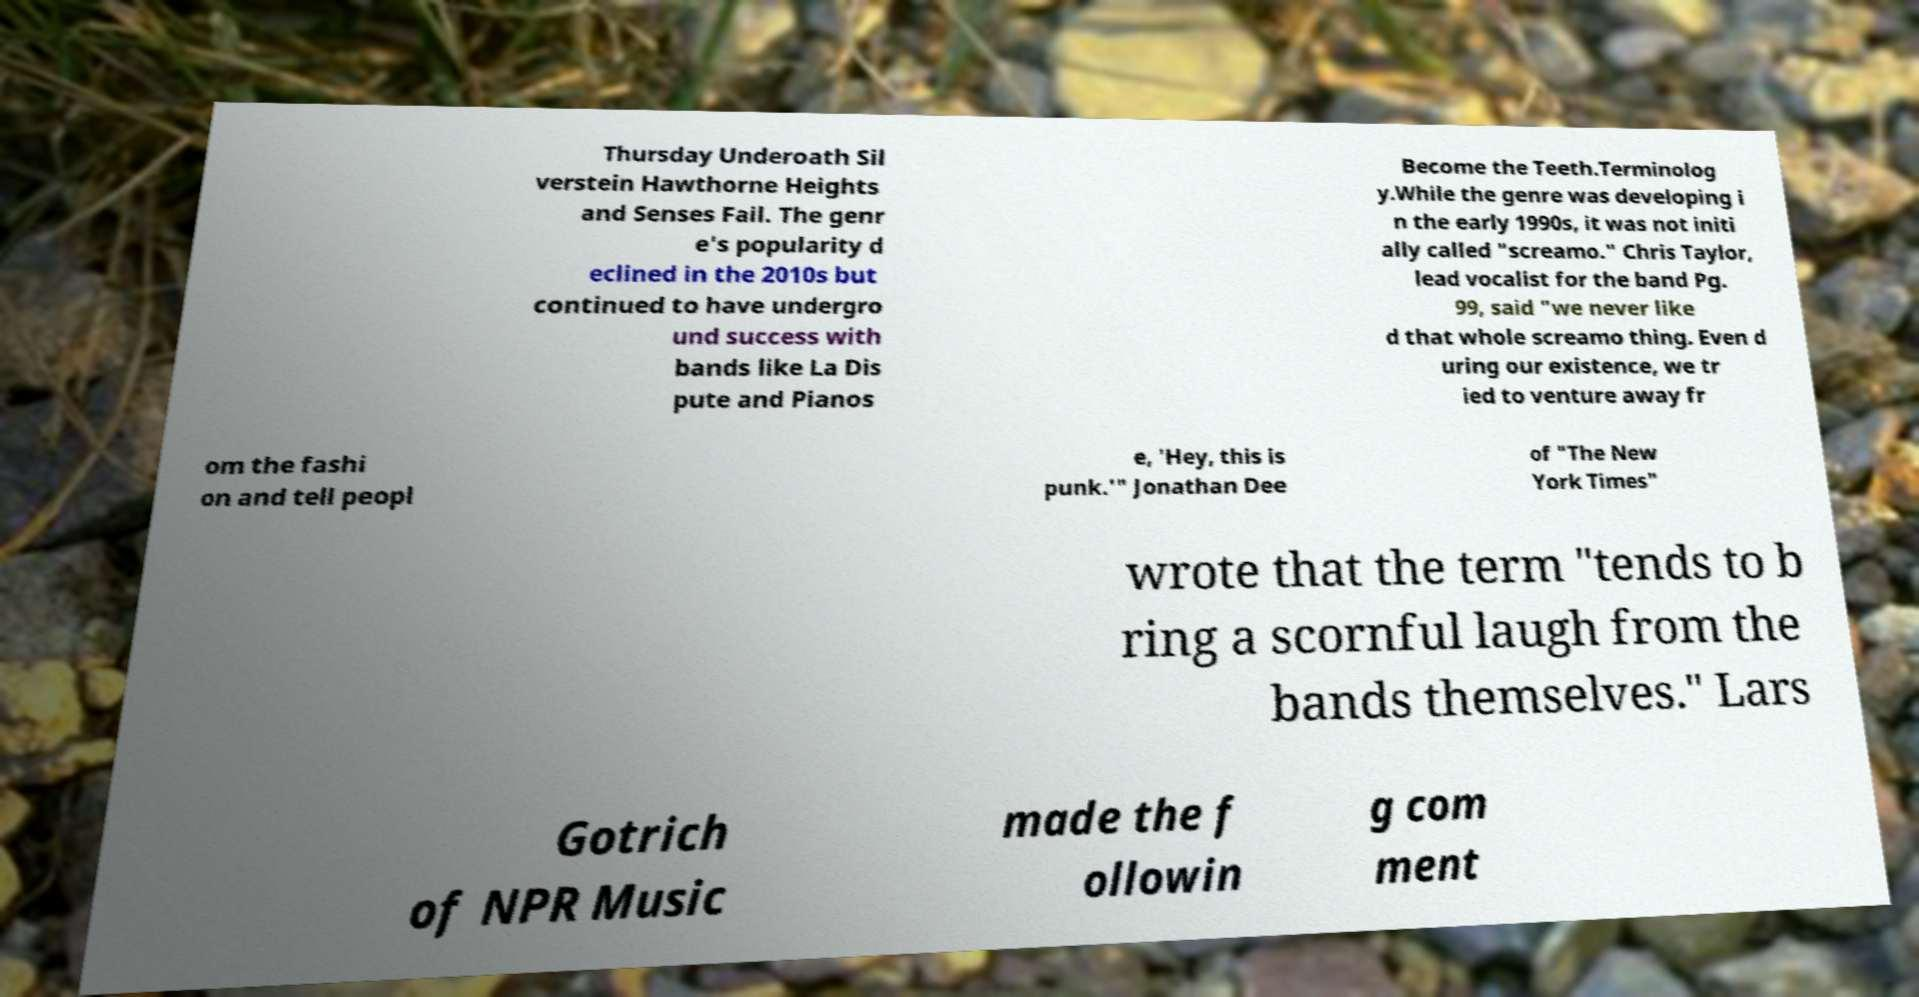Can you accurately transcribe the text from the provided image for me? Thursday Underoath Sil verstein Hawthorne Heights and Senses Fail. The genr e's popularity d eclined in the 2010s but continued to have undergro und success with bands like La Dis pute and Pianos Become the Teeth.Terminolog y.While the genre was developing i n the early 1990s, it was not initi ally called "screamo." Chris Taylor, lead vocalist for the band Pg. 99, said "we never like d that whole screamo thing. Even d uring our existence, we tr ied to venture away fr om the fashi on and tell peopl e, 'Hey, this is punk.'" Jonathan Dee of "The New York Times" wrote that the term "tends to b ring a scornful laugh from the bands themselves." Lars Gotrich of NPR Music made the f ollowin g com ment 